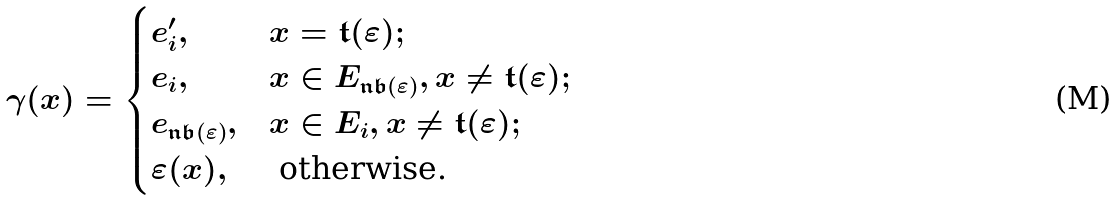<formula> <loc_0><loc_0><loc_500><loc_500>\gamma ( x ) = \begin{cases} e ^ { \prime } _ { i } , & x = \mathfrak { t } ( \varepsilon ) ; \\ e _ { i } , & x \in E _ { \mathfrak { n b } ( \varepsilon ) } , x \neq \mathfrak { t } ( \varepsilon ) ; \\ e _ { \mathfrak { n b } ( \varepsilon ) } , & x \in E _ { i } , x \neq \mathfrak { t } ( \varepsilon ) ; \\ \varepsilon ( x ) , & \text { otherwise.} \end{cases}</formula> 